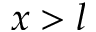Convert formula to latex. <formula><loc_0><loc_0><loc_500><loc_500>x > l</formula> 